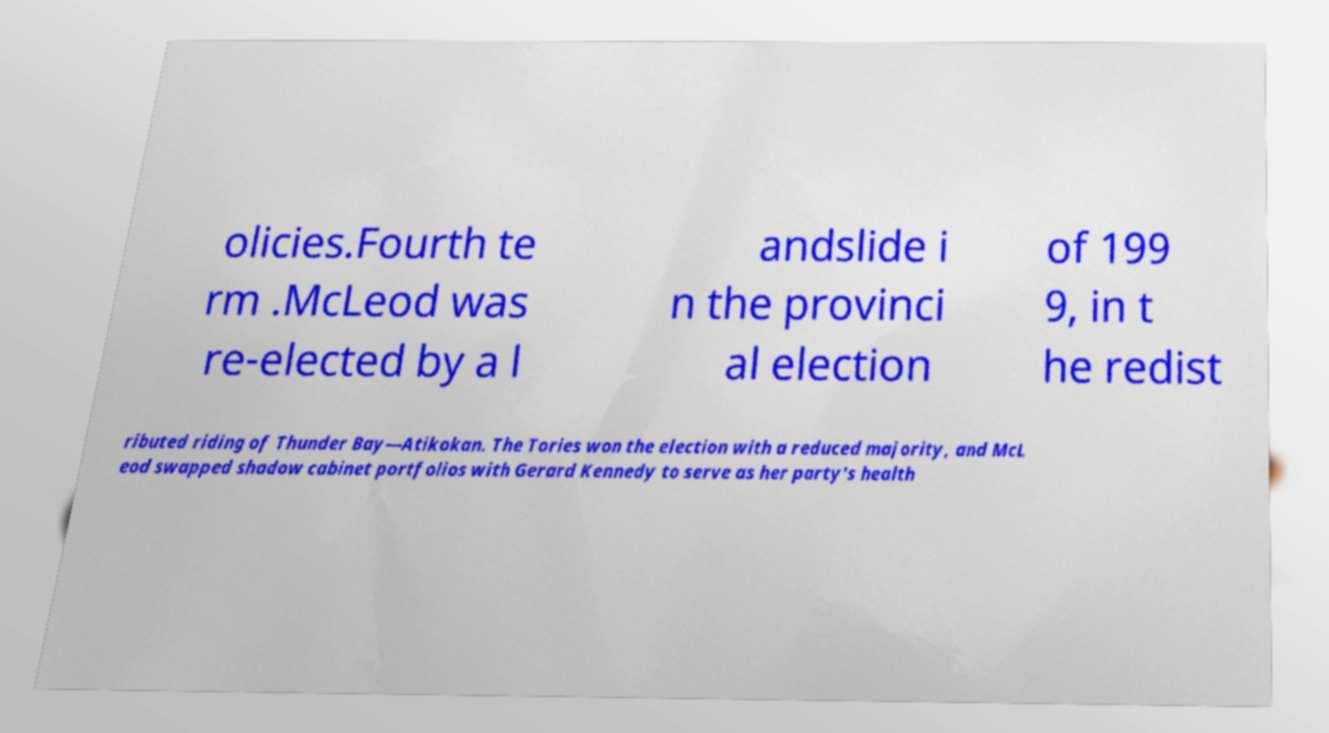Can you accurately transcribe the text from the provided image for me? olicies.Fourth te rm .McLeod was re-elected by a l andslide i n the provinci al election of 199 9, in t he redist ributed riding of Thunder Bay—Atikokan. The Tories won the election with a reduced majority, and McL eod swapped shadow cabinet portfolios with Gerard Kennedy to serve as her party's health 